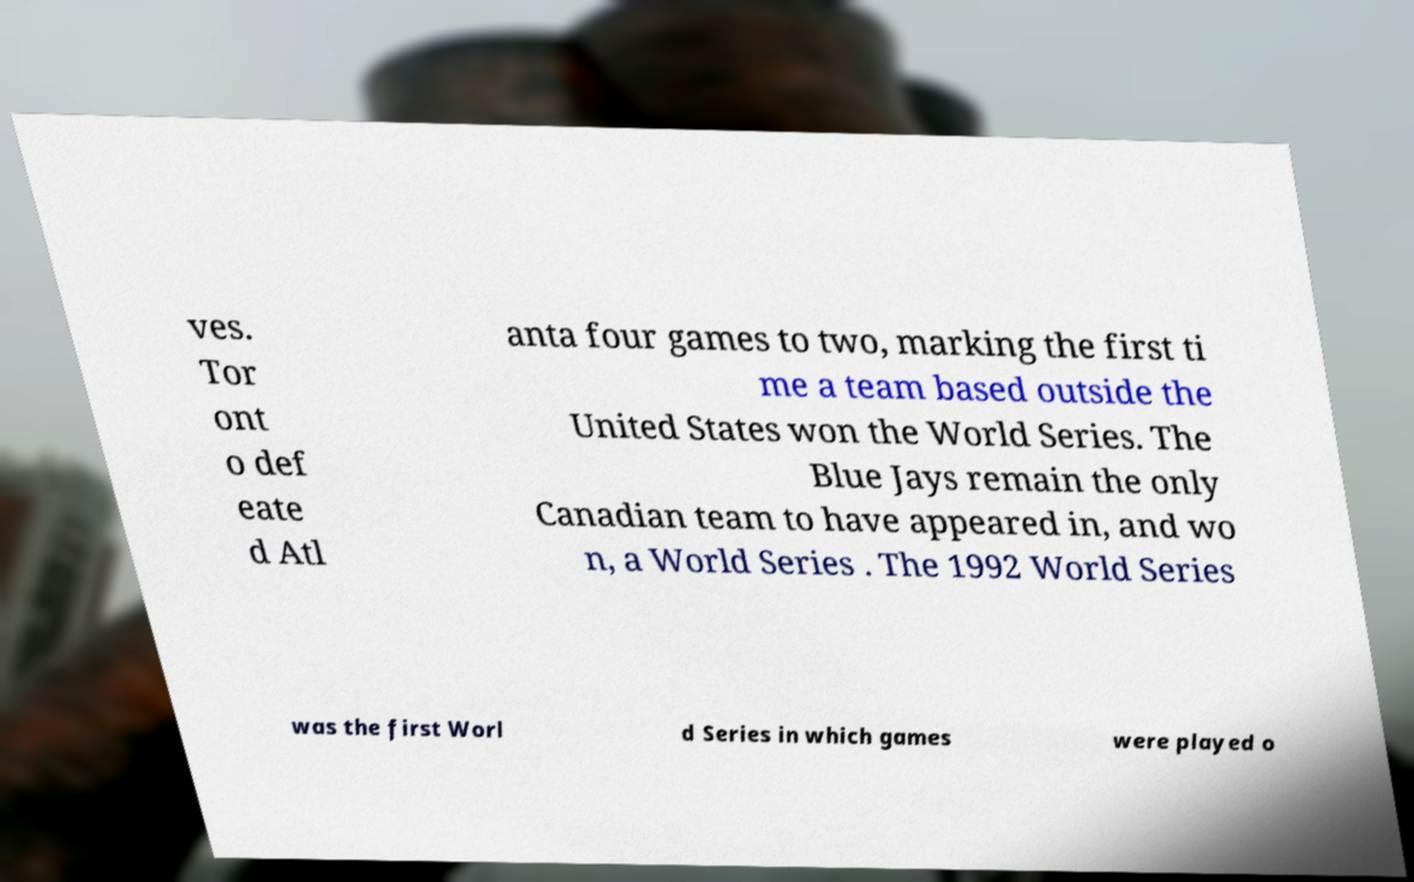Can you accurately transcribe the text from the provided image for me? ves. Tor ont o def eate d Atl anta four games to two, marking the first ti me a team based outside the United States won the World Series. The Blue Jays remain the only Canadian team to have appeared in, and wo n, a World Series . The 1992 World Series was the first Worl d Series in which games were played o 